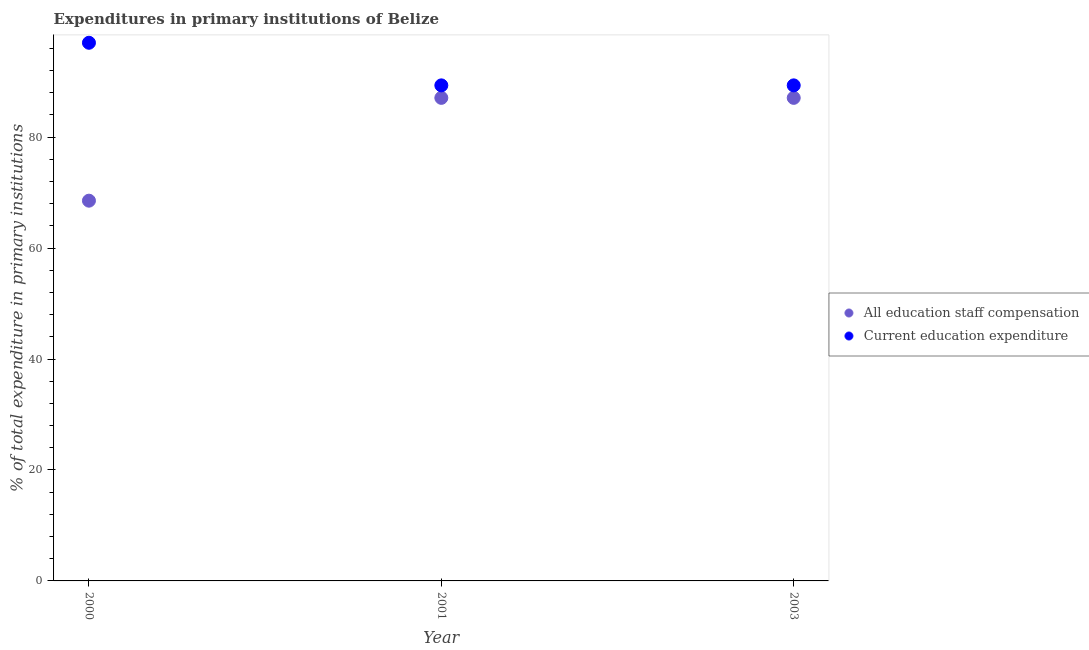How many different coloured dotlines are there?
Your answer should be very brief. 2. Is the number of dotlines equal to the number of legend labels?
Your answer should be compact. Yes. What is the expenditure in education in 2003?
Your answer should be compact. 89.32. Across all years, what is the maximum expenditure in education?
Give a very brief answer. 97. Across all years, what is the minimum expenditure in education?
Ensure brevity in your answer.  89.32. In which year was the expenditure in staff compensation maximum?
Your response must be concise. 2001. In which year was the expenditure in staff compensation minimum?
Ensure brevity in your answer.  2000. What is the total expenditure in education in the graph?
Keep it short and to the point. 275.65. What is the difference between the expenditure in education in 2000 and that in 2003?
Your response must be concise. 7.68. What is the difference between the expenditure in education in 2003 and the expenditure in staff compensation in 2001?
Offer a very short reply. 2.25. What is the average expenditure in education per year?
Make the answer very short. 91.88. In the year 2003, what is the difference between the expenditure in education and expenditure in staff compensation?
Provide a short and direct response. 2.25. Is the expenditure in education in 2000 less than that in 2001?
Offer a very short reply. No. What is the difference between the highest and the second highest expenditure in education?
Offer a terse response. 7.68. What is the difference between the highest and the lowest expenditure in education?
Keep it short and to the point. 7.68. Is the sum of the expenditure in education in 2000 and 2003 greater than the maximum expenditure in staff compensation across all years?
Ensure brevity in your answer.  Yes. Does the expenditure in staff compensation monotonically increase over the years?
Provide a succinct answer. No. Is the expenditure in staff compensation strictly greater than the expenditure in education over the years?
Provide a short and direct response. No. How many dotlines are there?
Offer a very short reply. 2. How many years are there in the graph?
Give a very brief answer. 3. What is the difference between two consecutive major ticks on the Y-axis?
Offer a very short reply. 20. Does the graph contain any zero values?
Provide a short and direct response. No. How are the legend labels stacked?
Provide a succinct answer. Vertical. What is the title of the graph?
Your response must be concise. Expenditures in primary institutions of Belize. Does "Subsidies" appear as one of the legend labels in the graph?
Your answer should be compact. No. What is the label or title of the X-axis?
Provide a short and direct response. Year. What is the label or title of the Y-axis?
Your response must be concise. % of total expenditure in primary institutions. What is the % of total expenditure in primary institutions of All education staff compensation in 2000?
Provide a short and direct response. 68.54. What is the % of total expenditure in primary institutions in Current education expenditure in 2000?
Give a very brief answer. 97. What is the % of total expenditure in primary institutions in All education staff compensation in 2001?
Offer a very short reply. 87.07. What is the % of total expenditure in primary institutions in Current education expenditure in 2001?
Give a very brief answer. 89.32. What is the % of total expenditure in primary institutions in All education staff compensation in 2003?
Ensure brevity in your answer.  87.07. What is the % of total expenditure in primary institutions in Current education expenditure in 2003?
Your answer should be very brief. 89.32. Across all years, what is the maximum % of total expenditure in primary institutions of All education staff compensation?
Provide a succinct answer. 87.07. Across all years, what is the maximum % of total expenditure in primary institutions of Current education expenditure?
Your response must be concise. 97. Across all years, what is the minimum % of total expenditure in primary institutions in All education staff compensation?
Your answer should be very brief. 68.54. Across all years, what is the minimum % of total expenditure in primary institutions in Current education expenditure?
Ensure brevity in your answer.  89.32. What is the total % of total expenditure in primary institutions in All education staff compensation in the graph?
Make the answer very short. 242.69. What is the total % of total expenditure in primary institutions in Current education expenditure in the graph?
Make the answer very short. 275.65. What is the difference between the % of total expenditure in primary institutions of All education staff compensation in 2000 and that in 2001?
Keep it short and to the point. -18.53. What is the difference between the % of total expenditure in primary institutions of Current education expenditure in 2000 and that in 2001?
Give a very brief answer. 7.68. What is the difference between the % of total expenditure in primary institutions in All education staff compensation in 2000 and that in 2003?
Give a very brief answer. -18.53. What is the difference between the % of total expenditure in primary institutions in Current education expenditure in 2000 and that in 2003?
Keep it short and to the point. 7.68. What is the difference between the % of total expenditure in primary institutions in All education staff compensation in 2000 and the % of total expenditure in primary institutions in Current education expenditure in 2001?
Your response must be concise. -20.78. What is the difference between the % of total expenditure in primary institutions in All education staff compensation in 2000 and the % of total expenditure in primary institutions in Current education expenditure in 2003?
Your response must be concise. -20.78. What is the difference between the % of total expenditure in primary institutions of All education staff compensation in 2001 and the % of total expenditure in primary institutions of Current education expenditure in 2003?
Keep it short and to the point. -2.25. What is the average % of total expenditure in primary institutions of All education staff compensation per year?
Ensure brevity in your answer.  80.9. What is the average % of total expenditure in primary institutions in Current education expenditure per year?
Offer a very short reply. 91.88. In the year 2000, what is the difference between the % of total expenditure in primary institutions of All education staff compensation and % of total expenditure in primary institutions of Current education expenditure?
Provide a succinct answer. -28.46. In the year 2001, what is the difference between the % of total expenditure in primary institutions in All education staff compensation and % of total expenditure in primary institutions in Current education expenditure?
Make the answer very short. -2.25. In the year 2003, what is the difference between the % of total expenditure in primary institutions in All education staff compensation and % of total expenditure in primary institutions in Current education expenditure?
Your response must be concise. -2.25. What is the ratio of the % of total expenditure in primary institutions in All education staff compensation in 2000 to that in 2001?
Your answer should be very brief. 0.79. What is the ratio of the % of total expenditure in primary institutions of Current education expenditure in 2000 to that in 2001?
Offer a very short reply. 1.09. What is the ratio of the % of total expenditure in primary institutions of All education staff compensation in 2000 to that in 2003?
Your response must be concise. 0.79. What is the ratio of the % of total expenditure in primary institutions of Current education expenditure in 2000 to that in 2003?
Make the answer very short. 1.09. What is the ratio of the % of total expenditure in primary institutions of Current education expenditure in 2001 to that in 2003?
Make the answer very short. 1. What is the difference between the highest and the second highest % of total expenditure in primary institutions of Current education expenditure?
Your answer should be very brief. 7.68. What is the difference between the highest and the lowest % of total expenditure in primary institutions in All education staff compensation?
Make the answer very short. 18.53. What is the difference between the highest and the lowest % of total expenditure in primary institutions of Current education expenditure?
Keep it short and to the point. 7.68. 